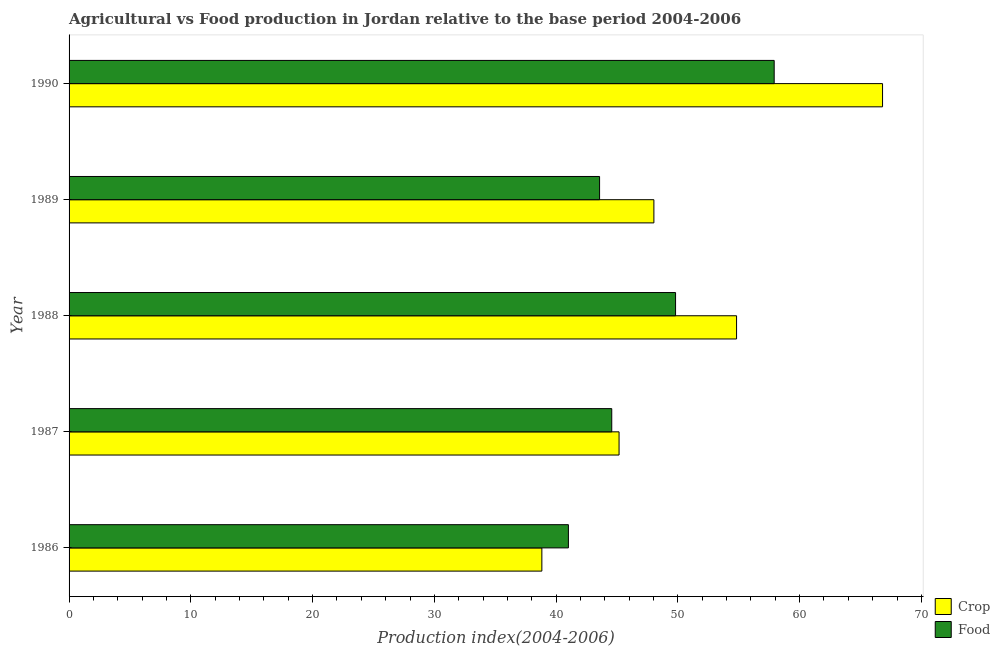How many groups of bars are there?
Offer a terse response. 5. How many bars are there on the 2nd tick from the top?
Ensure brevity in your answer.  2. In how many cases, is the number of bars for a given year not equal to the number of legend labels?
Your response must be concise. 0. What is the crop production index in 1988?
Provide a short and direct response. 54.82. Across all years, what is the maximum food production index?
Your answer should be compact. 57.91. Across all years, what is the minimum food production index?
Keep it short and to the point. 41.01. In which year was the food production index minimum?
Your answer should be compact. 1986. What is the total food production index in the graph?
Ensure brevity in your answer.  236.87. What is the difference between the food production index in 1987 and that in 1990?
Keep it short and to the point. -13.34. What is the difference between the crop production index in 1987 and the food production index in 1990?
Your response must be concise. -12.74. What is the average crop production index per year?
Offer a terse response. 50.73. What is the ratio of the crop production index in 1986 to that in 1990?
Offer a terse response. 0.58. Is the food production index in 1986 less than that in 1990?
Provide a short and direct response. Yes. Is the difference between the food production index in 1987 and 1989 greater than the difference between the crop production index in 1987 and 1989?
Your response must be concise. Yes. What is the difference between the highest and the lowest food production index?
Ensure brevity in your answer.  16.9. Is the sum of the food production index in 1986 and 1988 greater than the maximum crop production index across all years?
Ensure brevity in your answer.  Yes. What does the 1st bar from the top in 1988 represents?
Ensure brevity in your answer.  Food. What does the 1st bar from the bottom in 1986 represents?
Offer a very short reply. Crop. Are all the bars in the graph horizontal?
Your response must be concise. Yes. Does the graph contain any zero values?
Offer a very short reply. No. Does the graph contain grids?
Provide a short and direct response. No. What is the title of the graph?
Offer a very short reply. Agricultural vs Food production in Jordan relative to the base period 2004-2006. What is the label or title of the X-axis?
Your response must be concise. Production index(2004-2006). What is the Production index(2004-2006) of Crop in 1986?
Your response must be concise. 38.83. What is the Production index(2004-2006) in Food in 1986?
Make the answer very short. 41.01. What is the Production index(2004-2006) of Crop in 1987?
Provide a short and direct response. 45.17. What is the Production index(2004-2006) of Food in 1987?
Ensure brevity in your answer.  44.57. What is the Production index(2004-2006) of Crop in 1988?
Give a very brief answer. 54.82. What is the Production index(2004-2006) of Food in 1988?
Your response must be concise. 49.81. What is the Production index(2004-2006) in Crop in 1989?
Your answer should be very brief. 48.03. What is the Production index(2004-2006) in Food in 1989?
Your answer should be compact. 43.57. What is the Production index(2004-2006) of Crop in 1990?
Keep it short and to the point. 66.81. What is the Production index(2004-2006) of Food in 1990?
Ensure brevity in your answer.  57.91. Across all years, what is the maximum Production index(2004-2006) in Crop?
Your answer should be very brief. 66.81. Across all years, what is the maximum Production index(2004-2006) in Food?
Give a very brief answer. 57.91. Across all years, what is the minimum Production index(2004-2006) of Crop?
Give a very brief answer. 38.83. Across all years, what is the minimum Production index(2004-2006) of Food?
Provide a short and direct response. 41.01. What is the total Production index(2004-2006) of Crop in the graph?
Your answer should be very brief. 253.66. What is the total Production index(2004-2006) in Food in the graph?
Your answer should be compact. 236.87. What is the difference between the Production index(2004-2006) in Crop in 1986 and that in 1987?
Give a very brief answer. -6.34. What is the difference between the Production index(2004-2006) of Food in 1986 and that in 1987?
Offer a very short reply. -3.56. What is the difference between the Production index(2004-2006) in Crop in 1986 and that in 1988?
Ensure brevity in your answer.  -15.99. What is the difference between the Production index(2004-2006) of Food in 1986 and that in 1988?
Offer a terse response. -8.8. What is the difference between the Production index(2004-2006) in Crop in 1986 and that in 1989?
Your response must be concise. -9.2. What is the difference between the Production index(2004-2006) of Food in 1986 and that in 1989?
Ensure brevity in your answer.  -2.56. What is the difference between the Production index(2004-2006) of Crop in 1986 and that in 1990?
Give a very brief answer. -27.98. What is the difference between the Production index(2004-2006) of Food in 1986 and that in 1990?
Make the answer very short. -16.9. What is the difference between the Production index(2004-2006) in Crop in 1987 and that in 1988?
Provide a short and direct response. -9.65. What is the difference between the Production index(2004-2006) of Food in 1987 and that in 1988?
Offer a terse response. -5.24. What is the difference between the Production index(2004-2006) of Crop in 1987 and that in 1989?
Your answer should be very brief. -2.86. What is the difference between the Production index(2004-2006) of Food in 1987 and that in 1989?
Your answer should be very brief. 1. What is the difference between the Production index(2004-2006) in Crop in 1987 and that in 1990?
Your answer should be compact. -21.64. What is the difference between the Production index(2004-2006) in Food in 1987 and that in 1990?
Ensure brevity in your answer.  -13.34. What is the difference between the Production index(2004-2006) of Crop in 1988 and that in 1989?
Offer a very short reply. 6.79. What is the difference between the Production index(2004-2006) of Food in 1988 and that in 1989?
Ensure brevity in your answer.  6.24. What is the difference between the Production index(2004-2006) of Crop in 1988 and that in 1990?
Offer a very short reply. -11.99. What is the difference between the Production index(2004-2006) in Crop in 1989 and that in 1990?
Provide a succinct answer. -18.78. What is the difference between the Production index(2004-2006) in Food in 1989 and that in 1990?
Make the answer very short. -14.34. What is the difference between the Production index(2004-2006) in Crop in 1986 and the Production index(2004-2006) in Food in 1987?
Keep it short and to the point. -5.74. What is the difference between the Production index(2004-2006) in Crop in 1986 and the Production index(2004-2006) in Food in 1988?
Give a very brief answer. -10.98. What is the difference between the Production index(2004-2006) of Crop in 1986 and the Production index(2004-2006) of Food in 1989?
Make the answer very short. -4.74. What is the difference between the Production index(2004-2006) of Crop in 1986 and the Production index(2004-2006) of Food in 1990?
Offer a very short reply. -19.08. What is the difference between the Production index(2004-2006) in Crop in 1987 and the Production index(2004-2006) in Food in 1988?
Give a very brief answer. -4.64. What is the difference between the Production index(2004-2006) of Crop in 1987 and the Production index(2004-2006) of Food in 1990?
Ensure brevity in your answer.  -12.74. What is the difference between the Production index(2004-2006) of Crop in 1988 and the Production index(2004-2006) of Food in 1989?
Your response must be concise. 11.25. What is the difference between the Production index(2004-2006) in Crop in 1988 and the Production index(2004-2006) in Food in 1990?
Your response must be concise. -3.09. What is the difference between the Production index(2004-2006) in Crop in 1989 and the Production index(2004-2006) in Food in 1990?
Keep it short and to the point. -9.88. What is the average Production index(2004-2006) of Crop per year?
Keep it short and to the point. 50.73. What is the average Production index(2004-2006) of Food per year?
Make the answer very short. 47.37. In the year 1986, what is the difference between the Production index(2004-2006) of Crop and Production index(2004-2006) of Food?
Your response must be concise. -2.18. In the year 1988, what is the difference between the Production index(2004-2006) of Crop and Production index(2004-2006) of Food?
Keep it short and to the point. 5.01. In the year 1989, what is the difference between the Production index(2004-2006) in Crop and Production index(2004-2006) in Food?
Keep it short and to the point. 4.46. What is the ratio of the Production index(2004-2006) of Crop in 1986 to that in 1987?
Your answer should be compact. 0.86. What is the ratio of the Production index(2004-2006) of Food in 1986 to that in 1987?
Your answer should be very brief. 0.92. What is the ratio of the Production index(2004-2006) in Crop in 1986 to that in 1988?
Provide a succinct answer. 0.71. What is the ratio of the Production index(2004-2006) of Food in 1986 to that in 1988?
Keep it short and to the point. 0.82. What is the ratio of the Production index(2004-2006) of Crop in 1986 to that in 1989?
Give a very brief answer. 0.81. What is the ratio of the Production index(2004-2006) in Crop in 1986 to that in 1990?
Keep it short and to the point. 0.58. What is the ratio of the Production index(2004-2006) in Food in 1986 to that in 1990?
Offer a very short reply. 0.71. What is the ratio of the Production index(2004-2006) of Crop in 1987 to that in 1988?
Make the answer very short. 0.82. What is the ratio of the Production index(2004-2006) in Food in 1987 to that in 1988?
Your response must be concise. 0.89. What is the ratio of the Production index(2004-2006) in Crop in 1987 to that in 1989?
Offer a very short reply. 0.94. What is the ratio of the Production index(2004-2006) of Food in 1987 to that in 1989?
Your answer should be compact. 1.02. What is the ratio of the Production index(2004-2006) of Crop in 1987 to that in 1990?
Your response must be concise. 0.68. What is the ratio of the Production index(2004-2006) of Food in 1987 to that in 1990?
Your answer should be compact. 0.77. What is the ratio of the Production index(2004-2006) in Crop in 1988 to that in 1989?
Your answer should be compact. 1.14. What is the ratio of the Production index(2004-2006) in Food in 1988 to that in 1989?
Offer a terse response. 1.14. What is the ratio of the Production index(2004-2006) of Crop in 1988 to that in 1990?
Provide a short and direct response. 0.82. What is the ratio of the Production index(2004-2006) in Food in 1988 to that in 1990?
Offer a terse response. 0.86. What is the ratio of the Production index(2004-2006) of Crop in 1989 to that in 1990?
Give a very brief answer. 0.72. What is the ratio of the Production index(2004-2006) in Food in 1989 to that in 1990?
Keep it short and to the point. 0.75. What is the difference between the highest and the second highest Production index(2004-2006) in Crop?
Keep it short and to the point. 11.99. What is the difference between the highest and the second highest Production index(2004-2006) of Food?
Make the answer very short. 8.1. What is the difference between the highest and the lowest Production index(2004-2006) in Crop?
Your answer should be compact. 27.98. What is the difference between the highest and the lowest Production index(2004-2006) of Food?
Your answer should be compact. 16.9. 